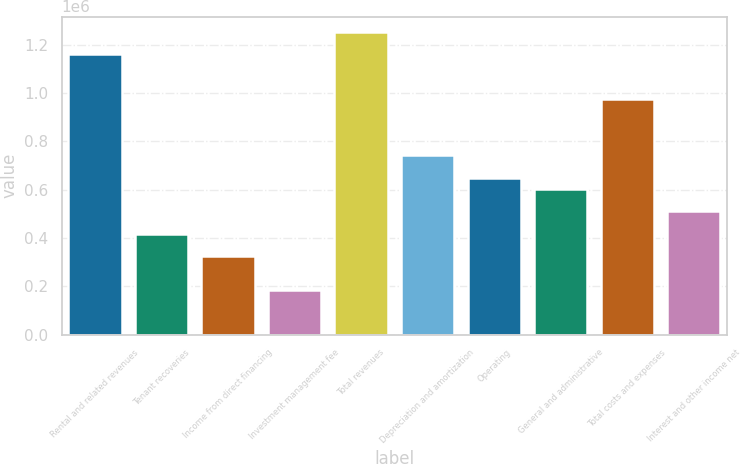Convert chart to OTSL. <chart><loc_0><loc_0><loc_500><loc_500><bar_chart><fcel>Rental and related revenues<fcel>Tenant recoveries<fcel>Income from direct financing<fcel>Investment management fee<fcel>Total revenues<fcel>Depreciation and amortization<fcel>Operating<fcel>General and administrative<fcel>Total costs and expenses<fcel>Interest and other income net<nl><fcel>1.16062e+06<fcel>417822<fcel>324973<fcel>185699<fcel>1.25347e+06<fcel>742795<fcel>649946<fcel>603521<fcel>974919<fcel>510672<nl></chart> 